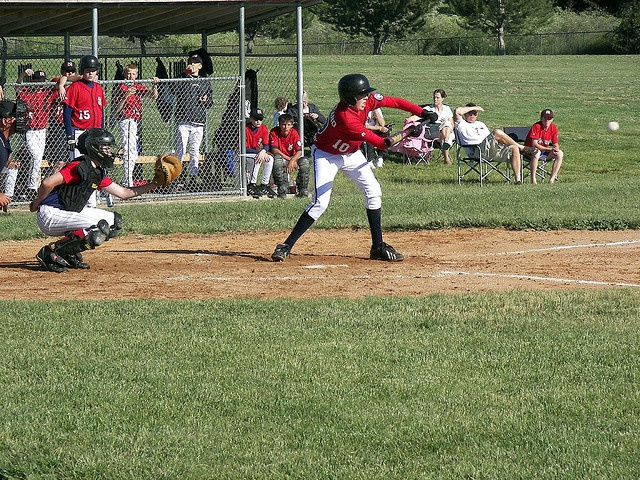Describe the objects in this image and their specific colors. I can see people in darkgray, black, white, and gray tones, people in darkgray, black, white, maroon, and gray tones, people in darkgray, black, gray, and white tones, people in darkgray, black, red, and brown tones, and people in darkgray, white, gray, and black tones in this image. 